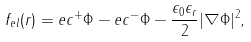Convert formula to latex. <formula><loc_0><loc_0><loc_500><loc_500>f _ { e l } ( r ) = e c ^ { + } \Phi - e c ^ { - } \Phi - \frac { \epsilon _ { 0 } \epsilon _ { r } } { 2 } | \nabla \Phi | ^ { 2 } ,</formula> 